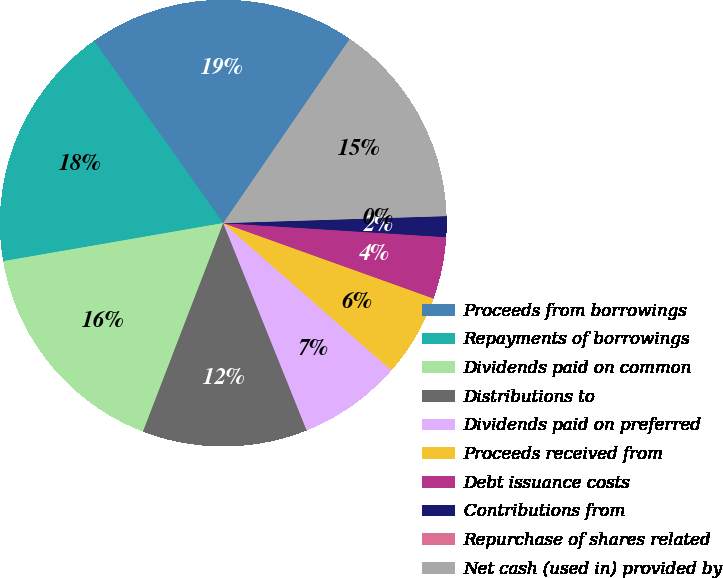Convert chart. <chart><loc_0><loc_0><loc_500><loc_500><pie_chart><fcel>Proceeds from borrowings<fcel>Repayments of borrowings<fcel>Dividends paid on common<fcel>Distributions to<fcel>Dividends paid on preferred<fcel>Proceeds received from<fcel>Debt issuance costs<fcel>Contributions from<fcel>Repurchase of shares related<fcel>Net cash (used in) provided by<nl><fcel>19.4%<fcel>17.91%<fcel>16.42%<fcel>11.94%<fcel>7.46%<fcel>5.97%<fcel>4.48%<fcel>1.5%<fcel>0.0%<fcel>14.92%<nl></chart> 